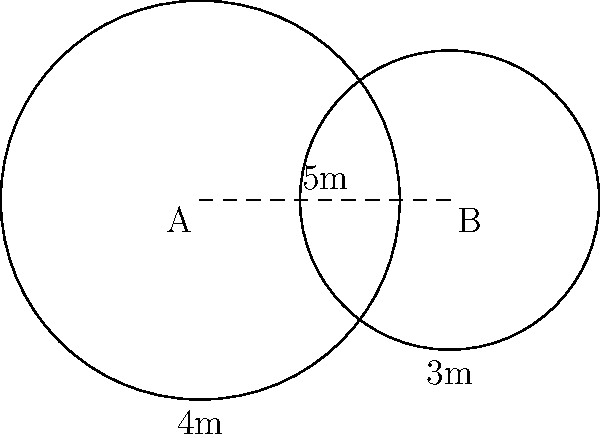In our warehouse, we have two automated cleaning robots, A and B, that operate in circular patterns. Robot A covers a radius of 4 meters, while Robot B covers a radius of 3 meters. The centers of their cleaning zones are 5 meters apart. To optimize our cleaning strategy, we need to calculate the area of overlap between these two cleaning zones. What is the area of the overlapping region, rounded to the nearest square meter? To solve this problem, we'll use the formula for the area of overlap between two circles. Let's break it down step-by-step:

1) First, we need to calculate the distance between the centers of the circles:
   $d = 5$ meters (given in the problem)

2) The radii of the circles are:
   $r_1 = 4$ meters (Robot A)
   $r_2 = 3$ meters (Robot B)

3) Now, we'll use the formula for the area of overlap:

   $A = r_1^2 \arccos(\frac{d^2 + r_1^2 - r_2^2}{2dr_1}) + r_2^2 \arccos(\frac{d^2 + r_2^2 - r_1^2}{2dr_2}) - \frac{1}{2}\sqrt{(-d+r_1+r_2)(d+r_1-r_2)(d-r_1+r_2)(d+r_1+r_2)}$

4) Let's substitute our values:

   $A = 4^2 \arccos(\frac{5^2 + 4^2 - 3^2}{2 \cdot 5 \cdot 4}) + 3^2 \arccos(\frac{5^2 + 3^2 - 4^2}{2 \cdot 5 \cdot 3}) - \frac{1}{2}\sqrt{(-5+4+3)(5+4-3)(5-4+3)(5+4+3)}$

5) Calculating this (you may use a calculator):

   $A \approx 16 \cdot 0.6435 + 9 \cdot 1.2490 - 0.5 \cdot 5.1962$
   $A \approx 10.2960 + 11.2410 - 2.5981$
   $A \approx 18.9389$ square meters

6) Rounding to the nearest square meter:

   $A \approx 19$ square meters
Answer: 19 square meters 